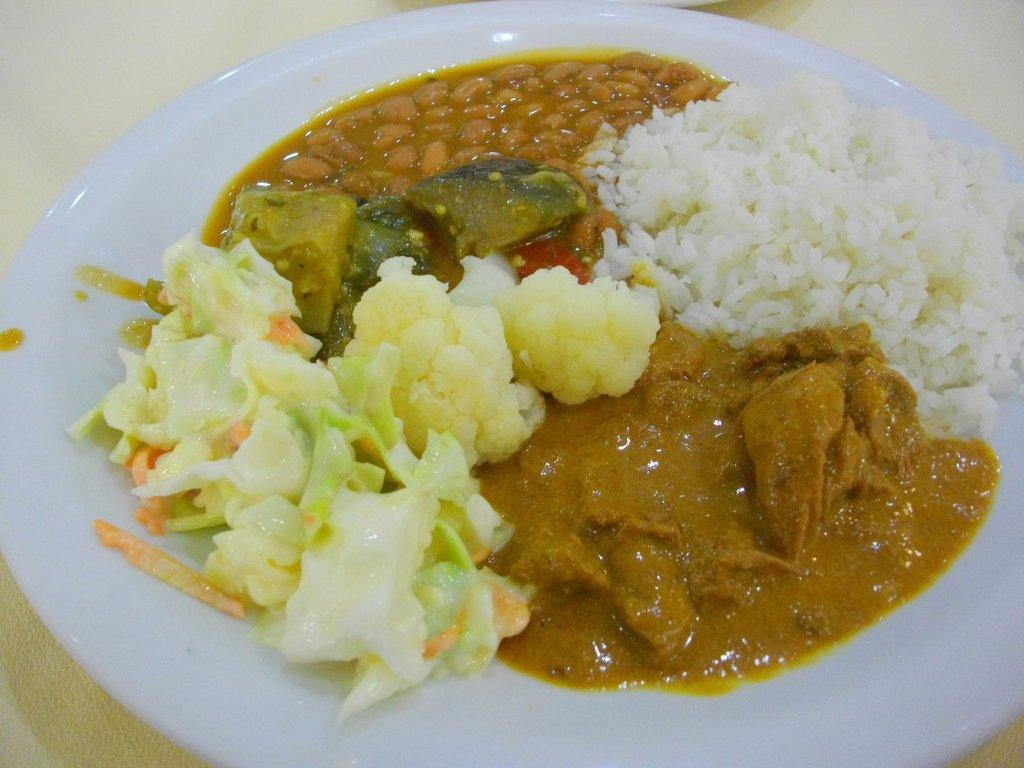What is present on the plate in the image? The plate contains food items. Where is the plate located in the image? The plate is placed on a platform. What purpose does the pencil serve in the image? There is no pencil present in the image, so it cannot serve any purpose in this context. 